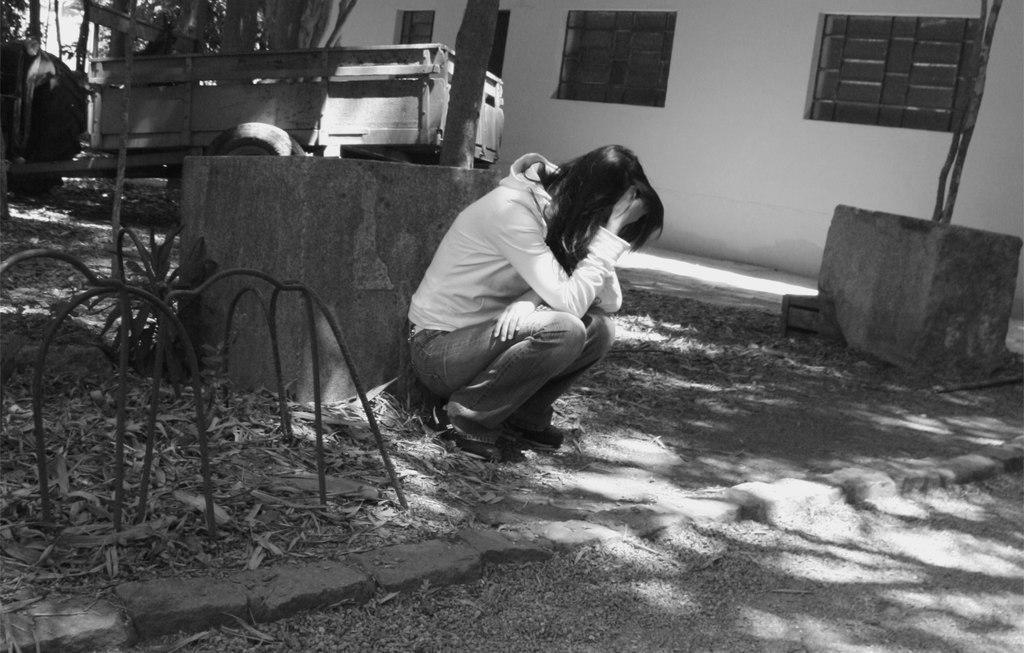Can you describe this image briefly? This is a black and white picture. In the middle of the picture, we see the woman is in squad position. Behind her, we see wall and iron rods. On the left side, we see a vehicle and trees. In the background, we see a white wall and the windows. At the bottom, we see small stones and dried leaves. 